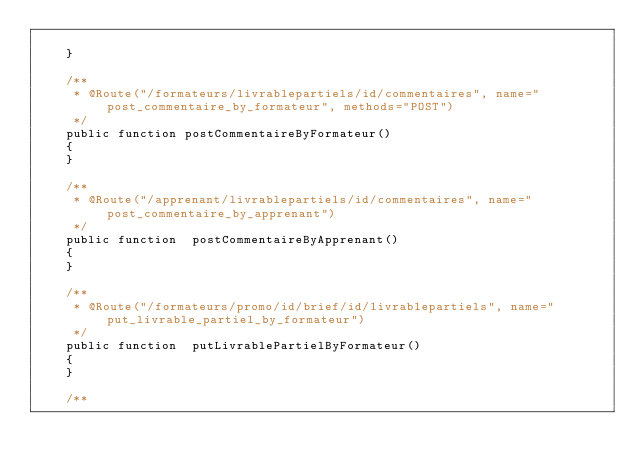<code> <loc_0><loc_0><loc_500><loc_500><_PHP_>        
    }

    /**
     * @Route("/formateurs/livrablepartiels/id/commentaires", name="post_commentaire_by_formateur", methods="POST")
     */
    public function postCommentaireByFormateur()
    {
    }

    /**
     * @Route("/apprenant/livrablepartiels/id/commentaires", name="post_commentaire_by_apprenant")
     */
    public function  postCommentaireByApprenant()
    {
    }
    
    /**
     * @Route("/formateurs/promo/id/brief/id/livrablepartiels", name="put_livrable_partiel_by_formateur")
     */
    public function  putLivrablePartielByFormateur()
    {
    }

    /**</code> 